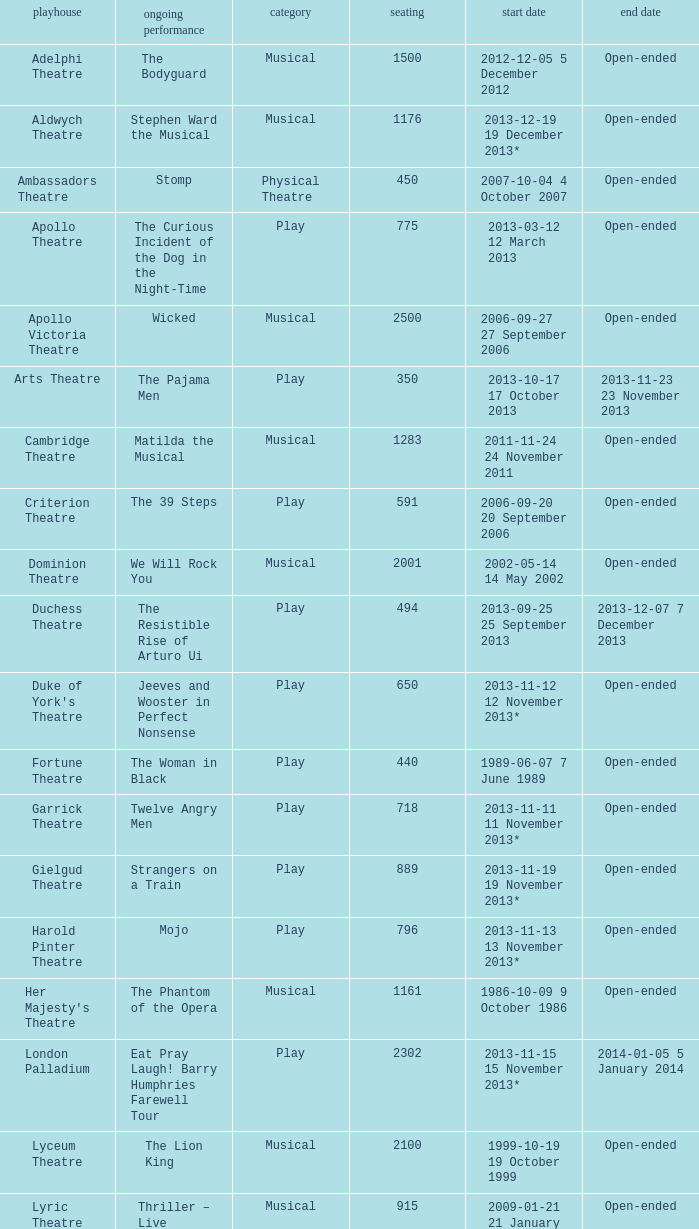What is the opening date of the musical at the adelphi theatre? 2012-12-05 5 December 2012. 